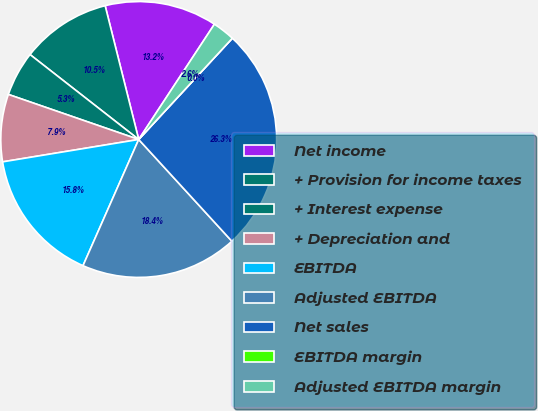Convert chart. <chart><loc_0><loc_0><loc_500><loc_500><pie_chart><fcel>Net income<fcel>+ Provision for income taxes<fcel>+ Interest expense<fcel>+ Depreciation and<fcel>EBITDA<fcel>Adjusted EBITDA<fcel>Net sales<fcel>EBITDA margin<fcel>Adjusted EBITDA margin<nl><fcel>13.16%<fcel>10.53%<fcel>5.26%<fcel>7.89%<fcel>15.79%<fcel>18.42%<fcel>26.32%<fcel>0.0%<fcel>2.63%<nl></chart> 